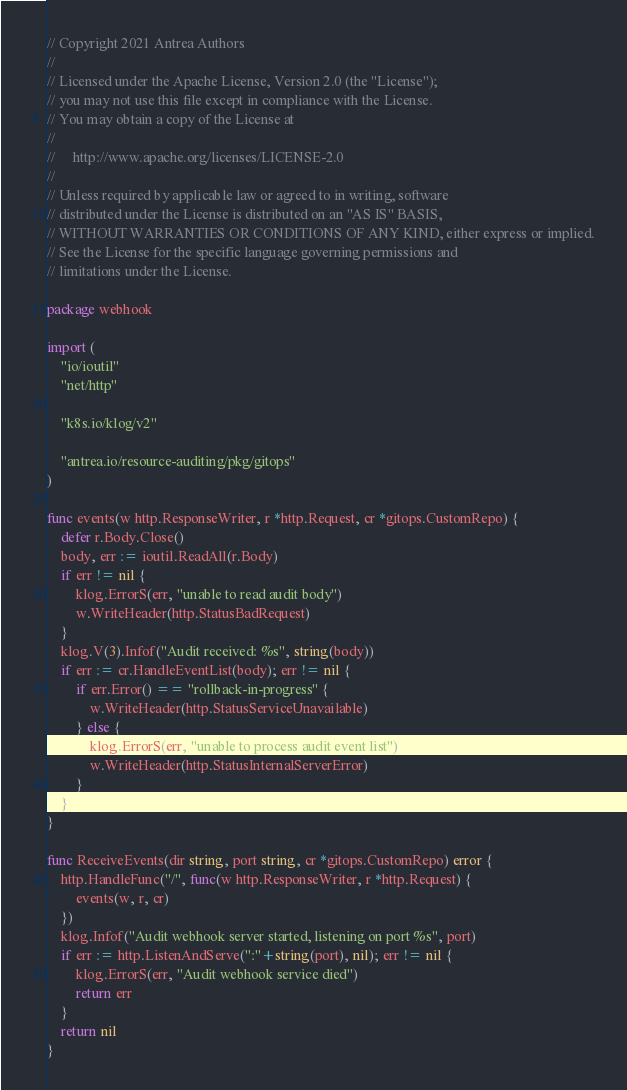<code> <loc_0><loc_0><loc_500><loc_500><_Go_>// Copyright 2021 Antrea Authors
//
// Licensed under the Apache License, Version 2.0 (the "License");
// you may not use this file except in compliance with the License.
// You may obtain a copy of the License at
//
//     http://www.apache.org/licenses/LICENSE-2.0
//
// Unless required by applicable law or agreed to in writing, software
// distributed under the License is distributed on an "AS IS" BASIS,
// WITHOUT WARRANTIES OR CONDITIONS OF ANY KIND, either express or implied.
// See the License for the specific language governing permissions and
// limitations under the License.

package webhook

import (
	"io/ioutil"
	"net/http"

	"k8s.io/klog/v2"

	"antrea.io/resource-auditing/pkg/gitops"
)

func events(w http.ResponseWriter, r *http.Request, cr *gitops.CustomRepo) {
	defer r.Body.Close()
	body, err := ioutil.ReadAll(r.Body)
	if err != nil {
		klog.ErrorS(err, "unable to read audit body")
		w.WriteHeader(http.StatusBadRequest)
	}
	klog.V(3).Infof("Audit received: %s", string(body))
	if err := cr.HandleEventList(body); err != nil {
		if err.Error() == "rollback-in-progress" {
			w.WriteHeader(http.StatusServiceUnavailable)
		} else {
			klog.ErrorS(err, "unable to process audit event list")
			w.WriteHeader(http.StatusInternalServerError)
		}
	}
}

func ReceiveEvents(dir string, port string, cr *gitops.CustomRepo) error {
	http.HandleFunc("/", func(w http.ResponseWriter, r *http.Request) {
		events(w, r, cr)
	})
	klog.Infof("Audit webhook server started, listening on port %s", port)
	if err := http.ListenAndServe(":"+string(port), nil); err != nil {
		klog.ErrorS(err, "Audit webhook service died")
		return err
	}
	return nil
}
</code> 